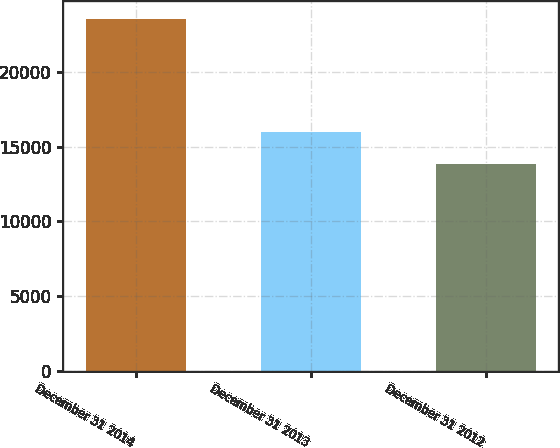<chart> <loc_0><loc_0><loc_500><loc_500><bar_chart><fcel>December 31 2014<fcel>December 31 2013<fcel>December 31 2012<nl><fcel>23603<fcel>15981<fcel>13834<nl></chart> 